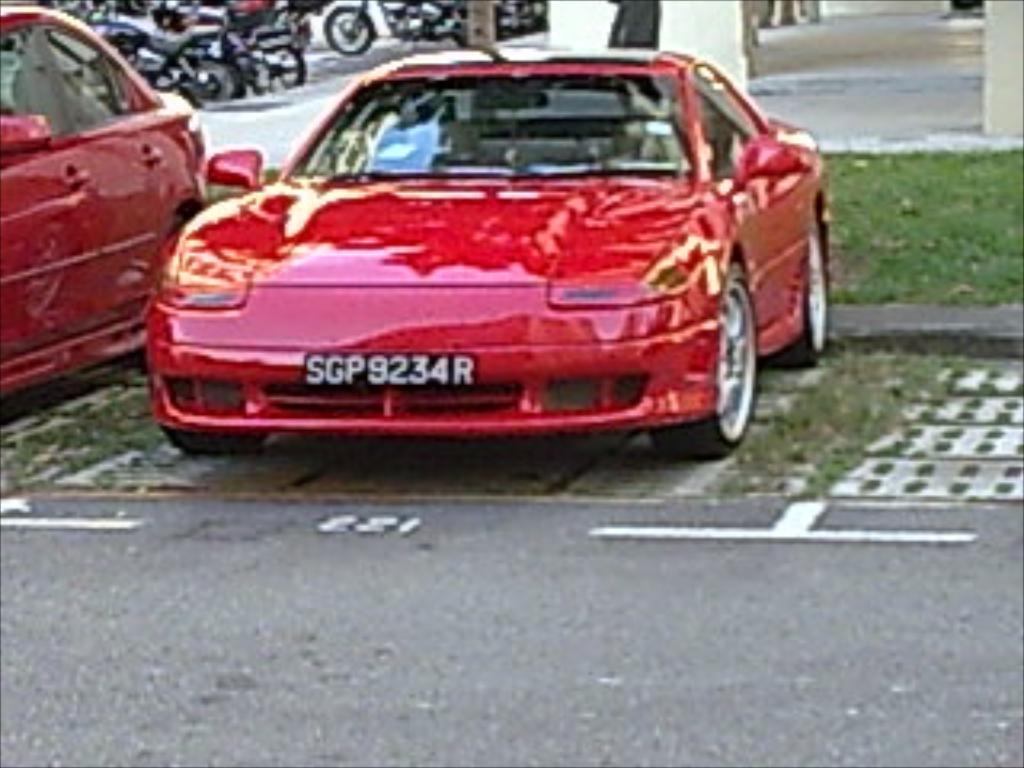How would you summarize this image in a sentence or two? In the center of the image cars are there. At the top of the image we can see some motorcycles, pillars, floor. In the middle of the image we can see some grass. At the bottom of the image there is a road. 